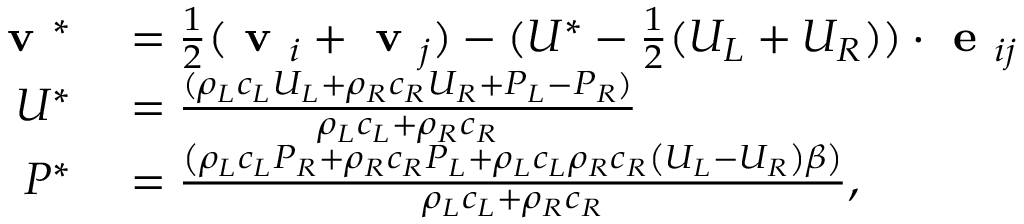Convert formula to latex. <formula><loc_0><loc_0><loc_500><loc_500>\begin{array} { r l } { v ^ { * } } & = \frac { 1 } { 2 } ( v _ { i } + v _ { j } ) - ( U ^ { * } - \frac { 1 } { 2 } ( U _ { L } + U _ { R } ) ) \cdot e _ { i j } } \\ { U ^ { * } } & = \frac { ( \rho _ { L } c _ { L } U _ { L } + \rho _ { R } c _ { R } U _ { R } + P _ { L } - P _ { R } ) } { \rho _ { L } c _ { L } + \rho _ { R } c _ { R } } } \\ { P ^ { * } } & = \frac { \left ( \rho _ { L } c _ { L } P _ { R } + \rho _ { R } c _ { R } P _ { L } + \rho _ { L } c _ { L } \rho _ { R } c _ { R } \left ( U _ { L } - U _ { R } \right ) \beta \right ) } { \rho _ { L } c _ { L } + \rho _ { R } c _ { R } } , } \end{array}</formula> 